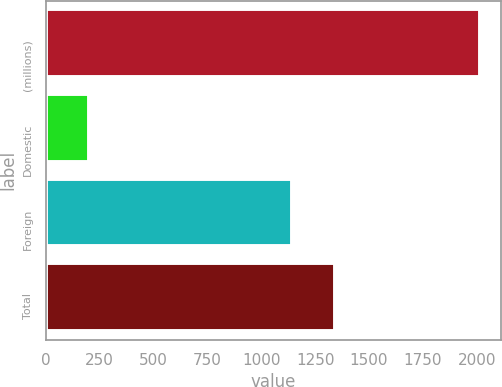<chart> <loc_0><loc_0><loc_500><loc_500><bar_chart><fcel>(millions)<fcel>Domestic<fcel>Foreign<fcel>Total<nl><fcel>2013<fcel>202<fcel>1142<fcel>1344<nl></chart> 